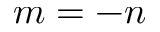Convert formula to latex. <formula><loc_0><loc_0><loc_500><loc_500>m = - n</formula> 